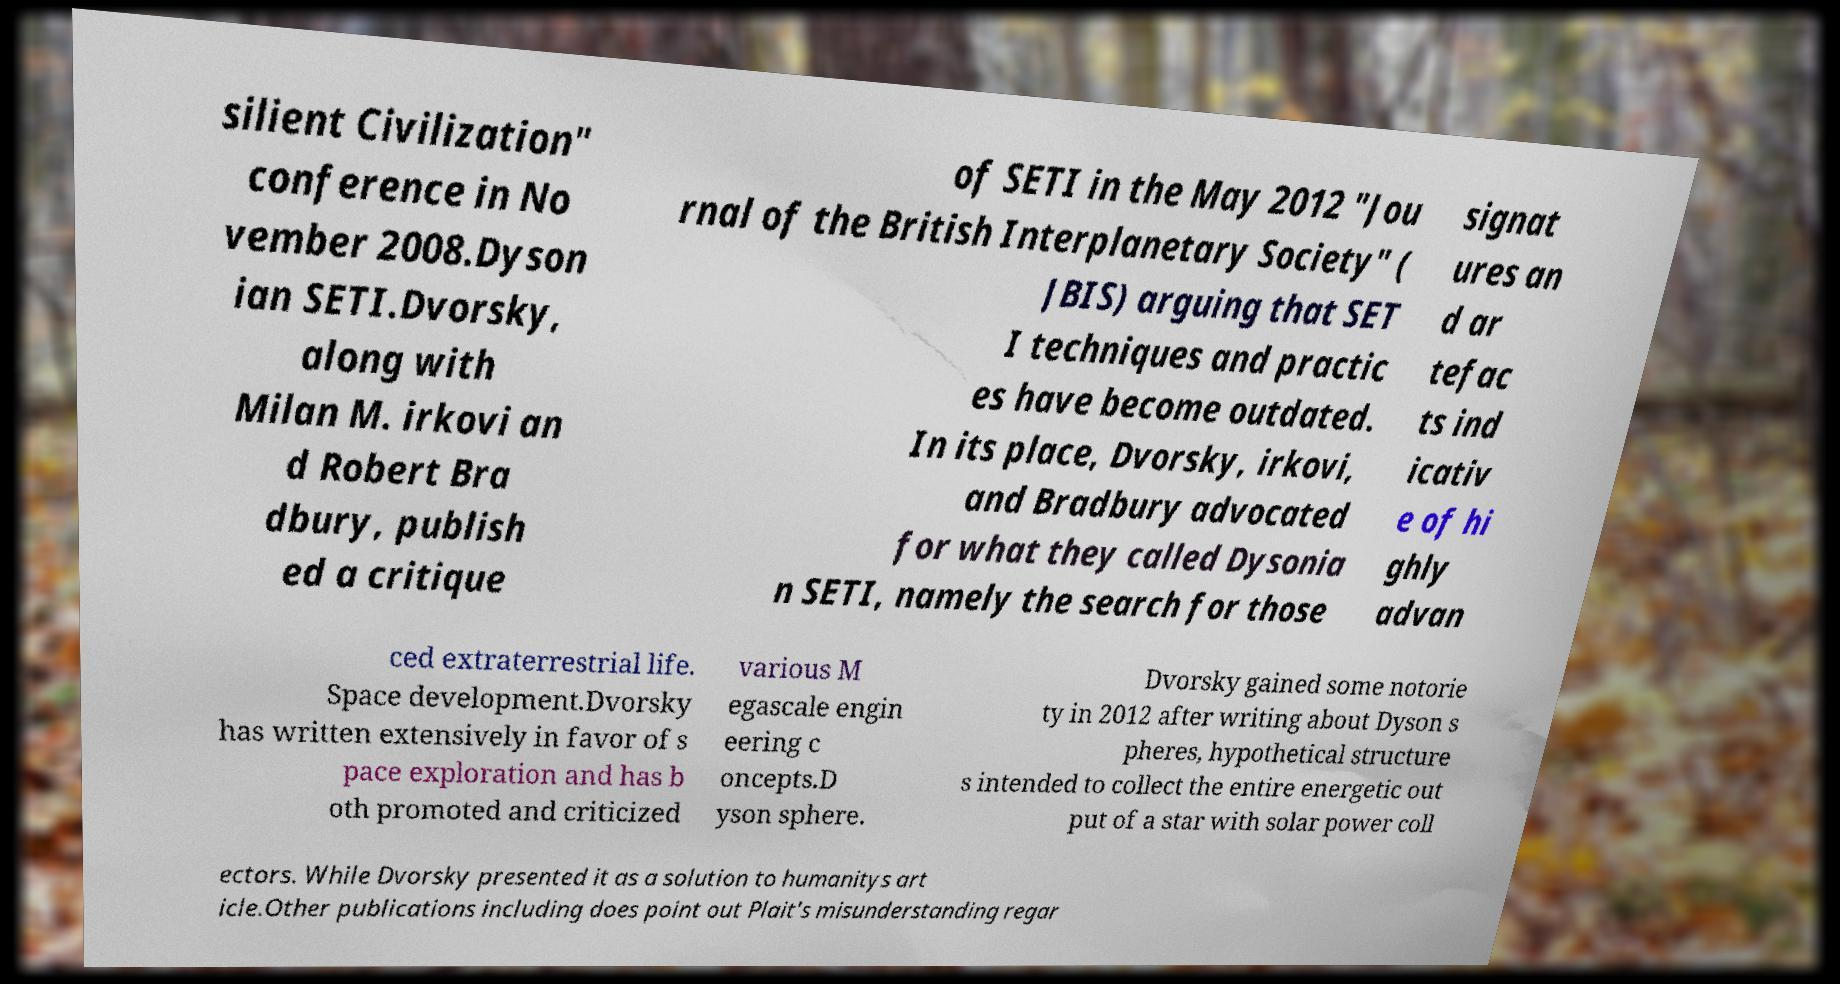There's text embedded in this image that I need extracted. Can you transcribe it verbatim? silient Civilization" conference in No vember 2008.Dyson ian SETI.Dvorsky, along with Milan M. irkovi an d Robert Bra dbury, publish ed a critique of SETI in the May 2012 "Jou rnal of the British Interplanetary Society" ( JBIS) arguing that SET I techniques and practic es have become outdated. In its place, Dvorsky, irkovi, and Bradbury advocated for what they called Dysonia n SETI, namely the search for those signat ures an d ar tefac ts ind icativ e of hi ghly advan ced extraterrestrial life. Space development.Dvorsky has written extensively in favor of s pace exploration and has b oth promoted and criticized various M egascale engin eering c oncepts.D yson sphere. Dvorsky gained some notorie ty in 2012 after writing about Dyson s pheres, hypothetical structure s intended to collect the entire energetic out put of a star with solar power coll ectors. While Dvorsky presented it as a solution to humanitys art icle.Other publications including does point out Plait's misunderstanding regar 